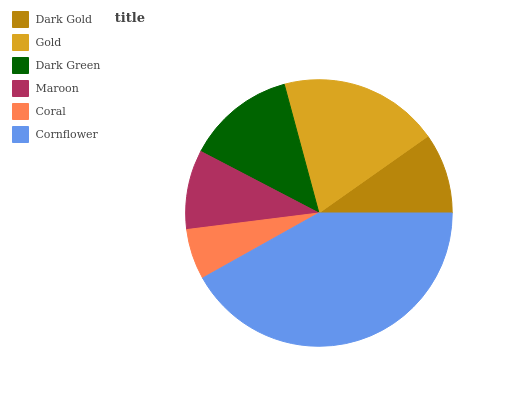Is Coral the minimum?
Answer yes or no. Yes. Is Cornflower the maximum?
Answer yes or no. Yes. Is Gold the minimum?
Answer yes or no. No. Is Gold the maximum?
Answer yes or no. No. Is Gold greater than Dark Gold?
Answer yes or no. Yes. Is Dark Gold less than Gold?
Answer yes or no. Yes. Is Dark Gold greater than Gold?
Answer yes or no. No. Is Gold less than Dark Gold?
Answer yes or no. No. Is Dark Green the high median?
Answer yes or no. Yes. Is Dark Gold the low median?
Answer yes or no. Yes. Is Dark Gold the high median?
Answer yes or no. No. Is Gold the low median?
Answer yes or no. No. 